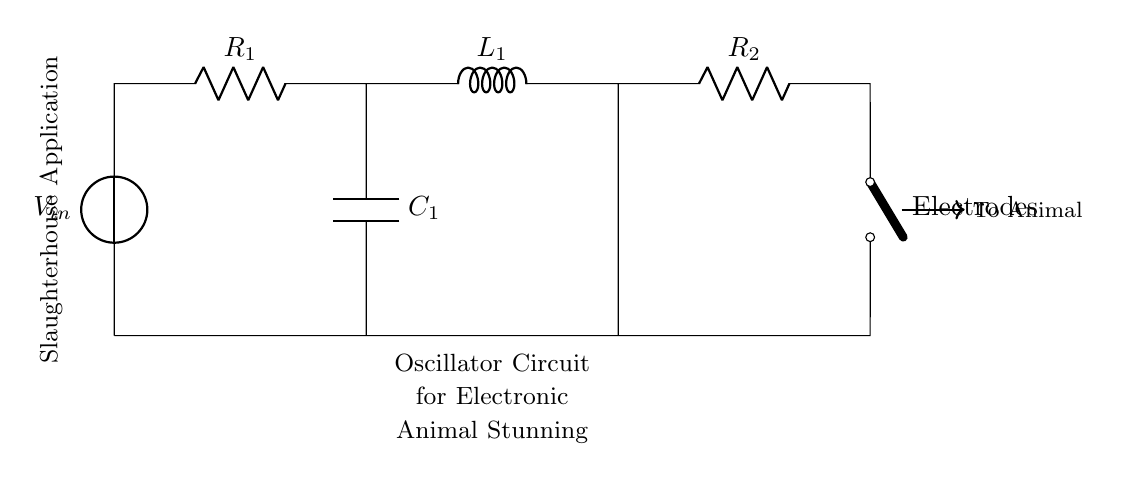What is the input voltage in this circuit? The input voltage is denoted as V_in, represented by the voltage source symbol in the circuit. The exact value of V_in is not provided, but it serves as the initial voltage for the circuit.
Answer: V_in What components are in this oscillator circuit? The components are a voltage source, two resistors (R_1, R_2), one inductor (L_1), and one capacitor (C_1). These components are essential in forming the oscillator circuit.
Answer: Voltage source, two resistors, one inductor, one capacitor What role does the inductor play in this circuit? The inductor (L_1) is part of the oscillator circuit that helps store energy in a magnetic field and contributes to the oscillation behavior of the circuit through its inductance property.
Answer: Energy storage How many resistors are in this circuit? There are two resistors in the circuit, indicated as R_1 and R_2. They are connected in the circuit to limit current and influence voltage drops.
Answer: Two What happens when the switch is closed? When the switch is closed, the circuit becomes complete, allowing current to flow through the components, which enables the oscillator to function and generate pulses for stunning.
Answer: Current flows How does adding a capacitor affect the oscillation frequency? The capacitor (C_1) in the circuit affects the time constant and resonance frequency; specifically, increasing capacitance generally decreases frequency, while decreasing capacitance increases frequency, altering the oscillator's behavior.
Answer: Decreases frequency 